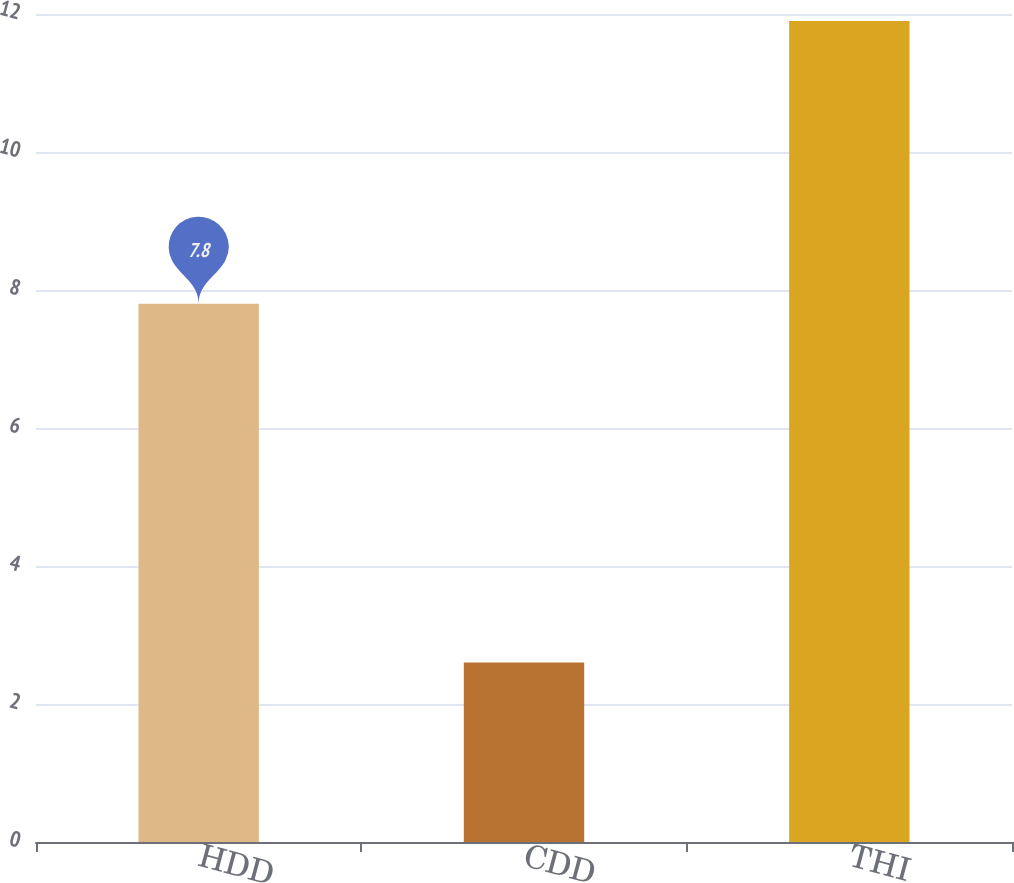<chart> <loc_0><loc_0><loc_500><loc_500><bar_chart><fcel>HDD<fcel>CDD<fcel>THI<nl><fcel>7.8<fcel>2.6<fcel>11.9<nl></chart> 